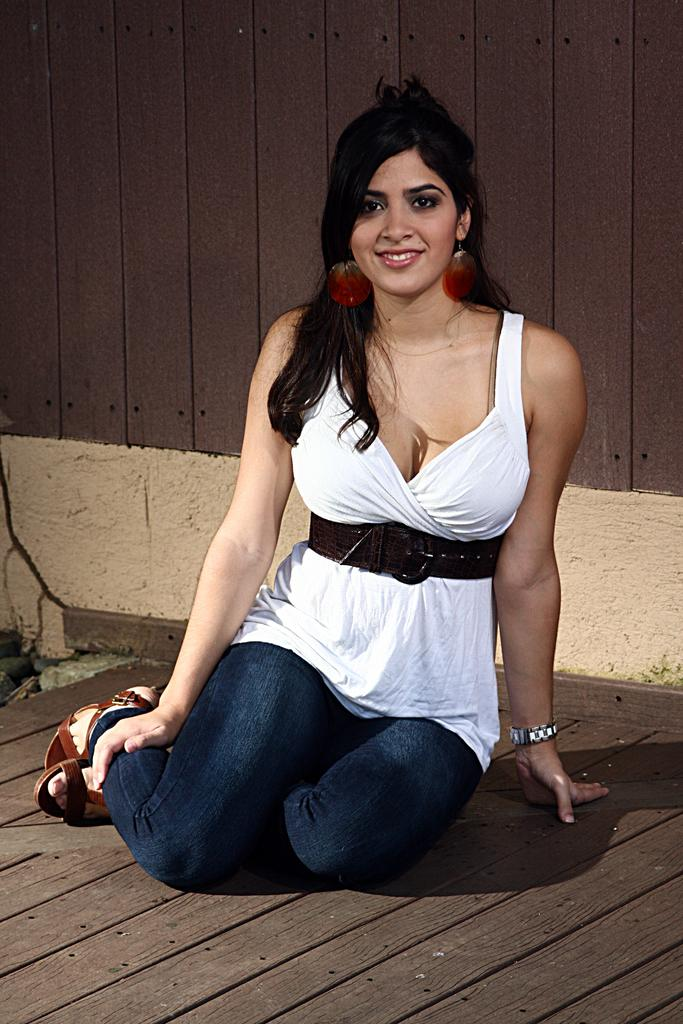Who is the main subject in the image? There is a girl in the image. What is the girl doing in the image? The girl is sitting on the wooden floor. How does the girl appear to be feeling in the image? The girl has a smile on her face, indicating that she is happy or content. What can be seen in the background of the image? There is a wooden wall in the background of the image. What type of pancake is the girl holding in the image? There is no pancake present in the image; the girl is sitting on the wooden floor with a smile on her face. 